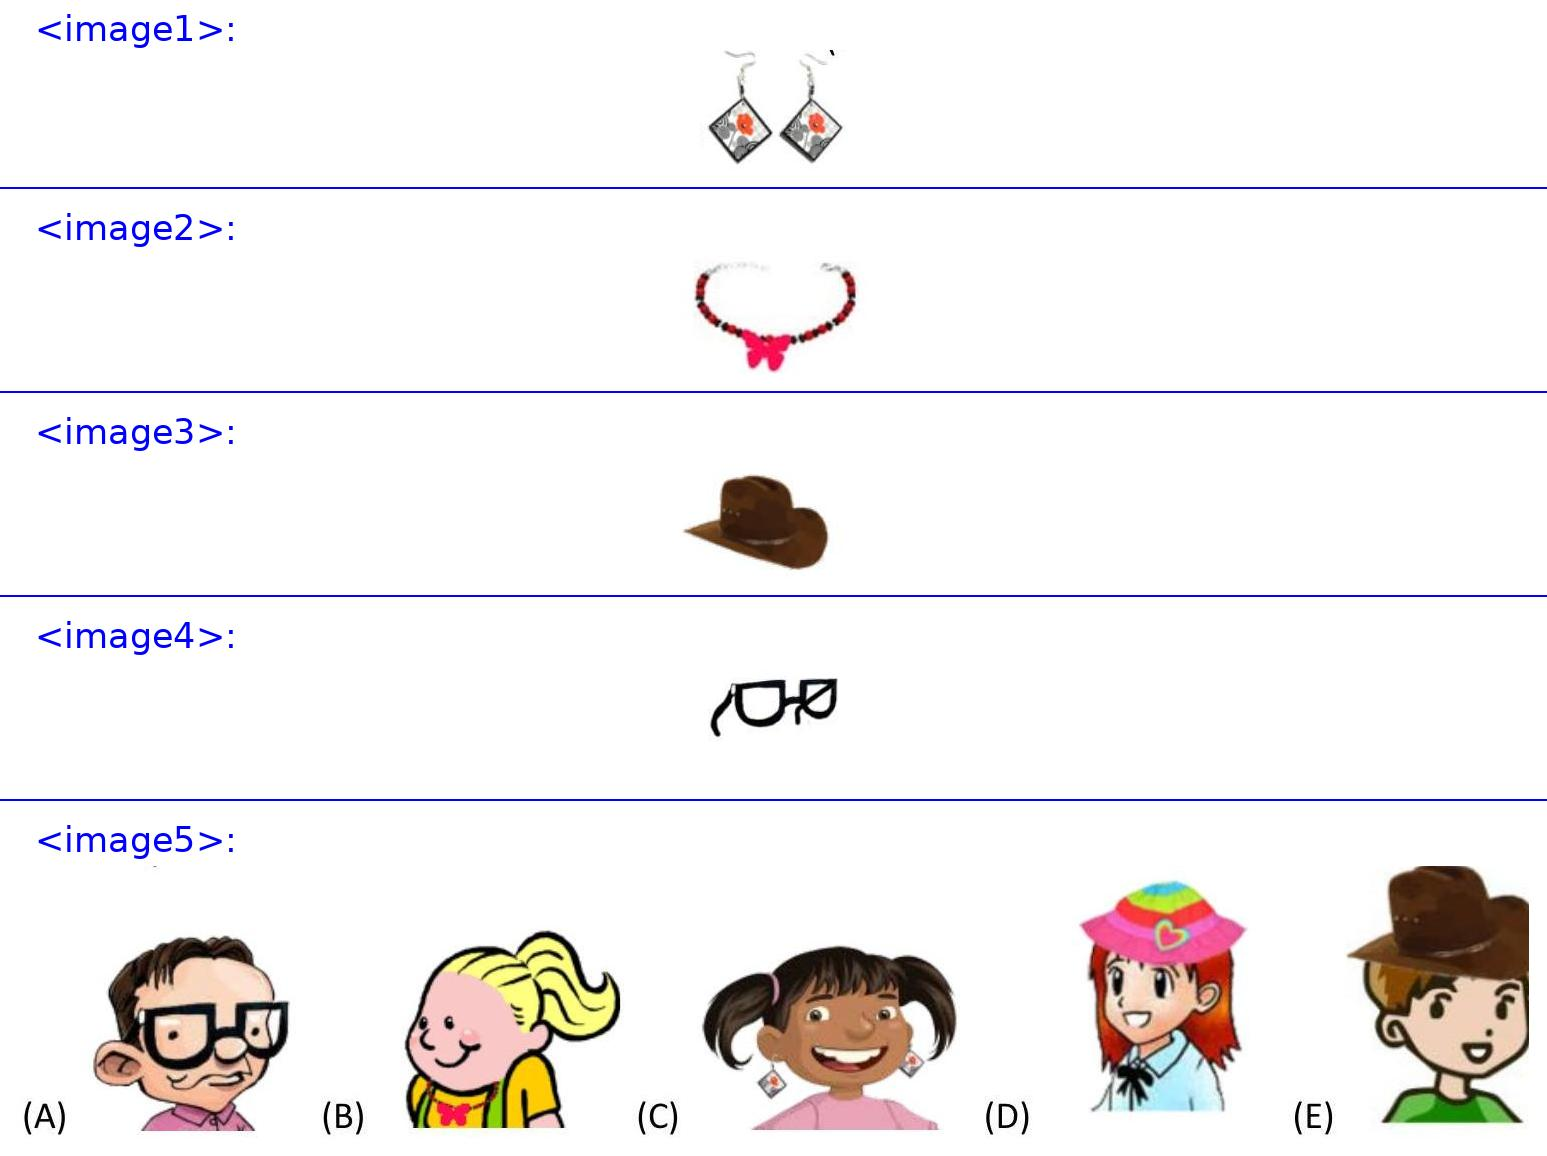Anna has .
Barbara gave Eva <image2>.
Josef has a <image3>.
Bob has <image4>.
Who is Barbara?
<image5> Choices: ['A', 'B', 'C', 'D', 'E'] Answer is D. 